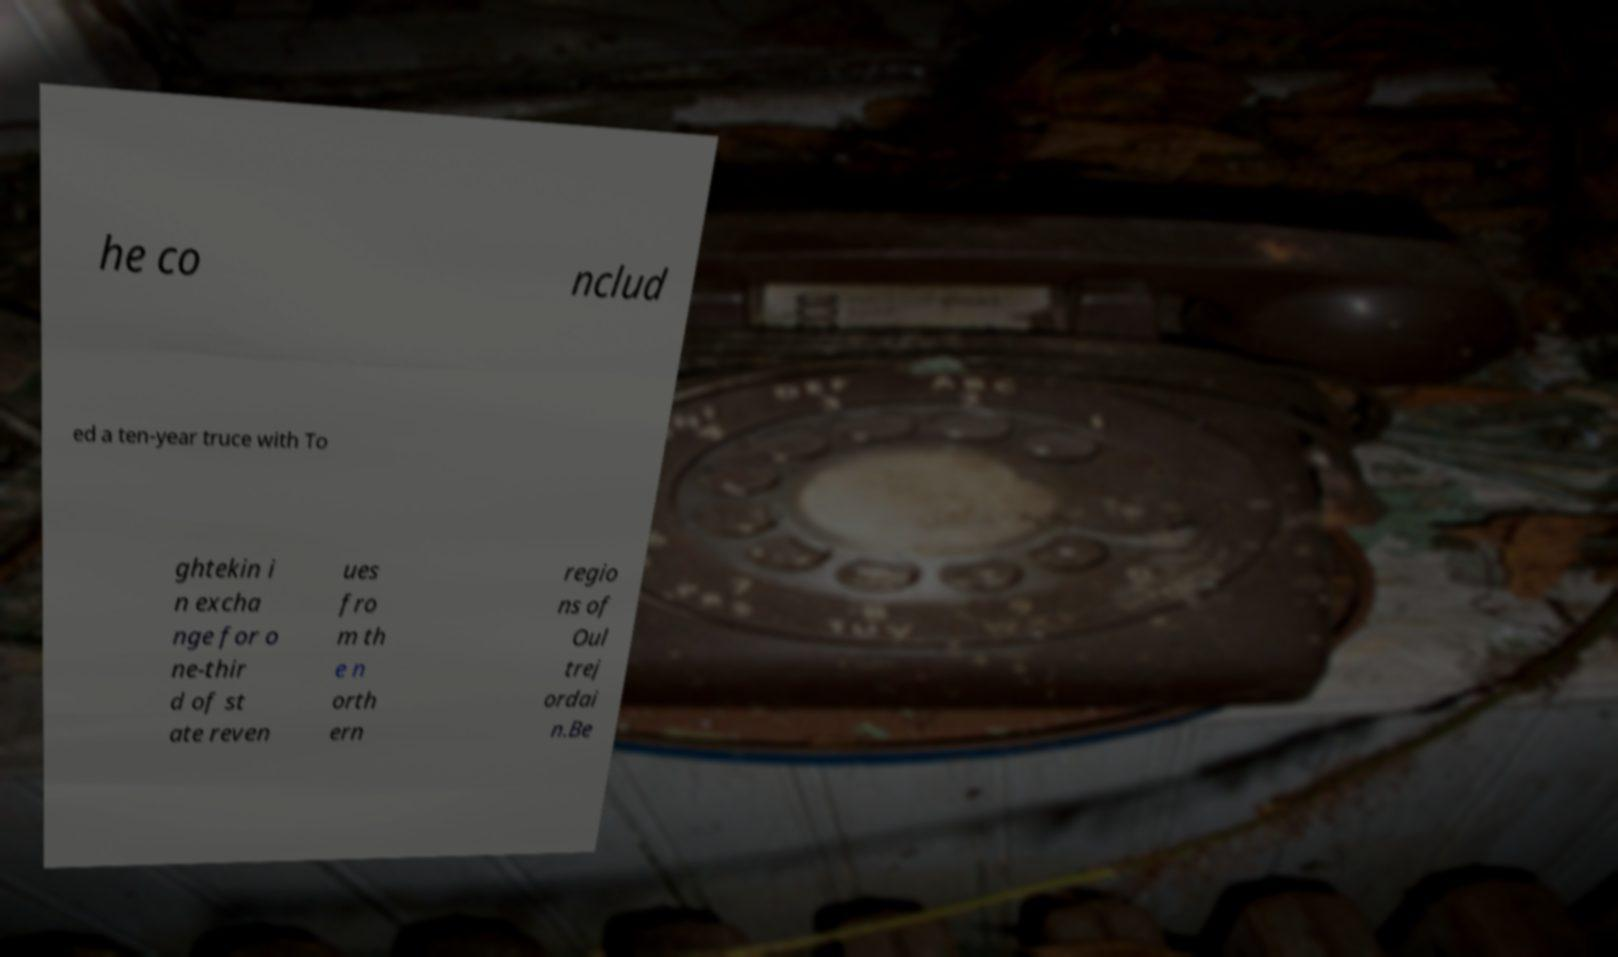Can you read and provide the text displayed in the image?This photo seems to have some interesting text. Can you extract and type it out for me? he co nclud ed a ten-year truce with To ghtekin i n excha nge for o ne-thir d of st ate reven ues fro m th e n orth ern regio ns of Oul trej ordai n.Be 